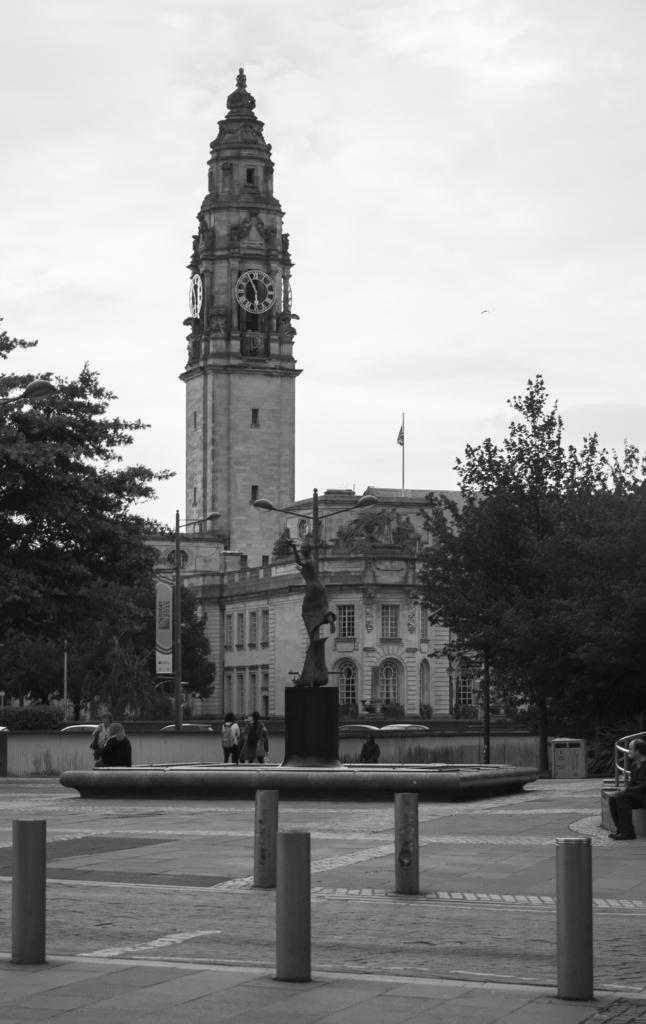Can you describe this image briefly? In the foreground of this image, there are few bollards on the pavement, a statue, few persons sitting and standing, poles, trees, flag, building and the cloud. 